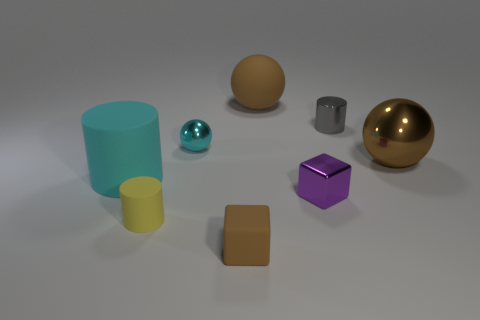Is the color of the small metal cylinder the same as the big matte thing behind the cyan ball?
Your answer should be very brief. No. There is a gray thing that is the same size as the shiny block; what material is it?
Provide a short and direct response. Metal. Is there a blue block made of the same material as the gray thing?
Offer a very short reply. No. How many brown rubber balls are there?
Provide a short and direct response. 1. Is the small gray thing made of the same material as the big brown ball in front of the cyan metal thing?
Ensure brevity in your answer.  Yes. What material is the other sphere that is the same color as the big rubber sphere?
Your answer should be very brief. Metal. How many objects have the same color as the big cylinder?
Give a very brief answer. 1. How big is the gray object?
Your response must be concise. Small. Does the tiny cyan object have the same shape as the brown rubber thing behind the yellow thing?
Make the answer very short. Yes. What color is the other small thing that is the same material as the small yellow thing?
Provide a short and direct response. Brown. 